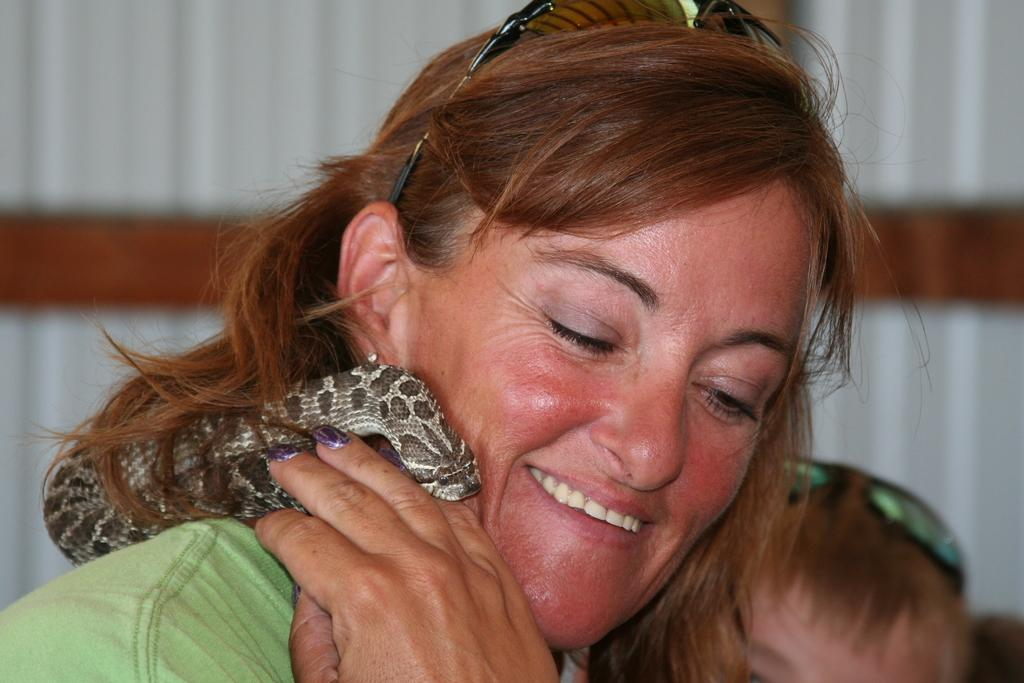Who is present in the image? There is a woman in the image. What is the woman holding? The woman is holding a scarf. Are there any other people in the image besides the woman? Yes, there is another person in the image. What type of skirt is the cloud wearing in the image? There is no cloud or skirt present in the image. How many cents are visible in the image? There are no cents present in the image. 